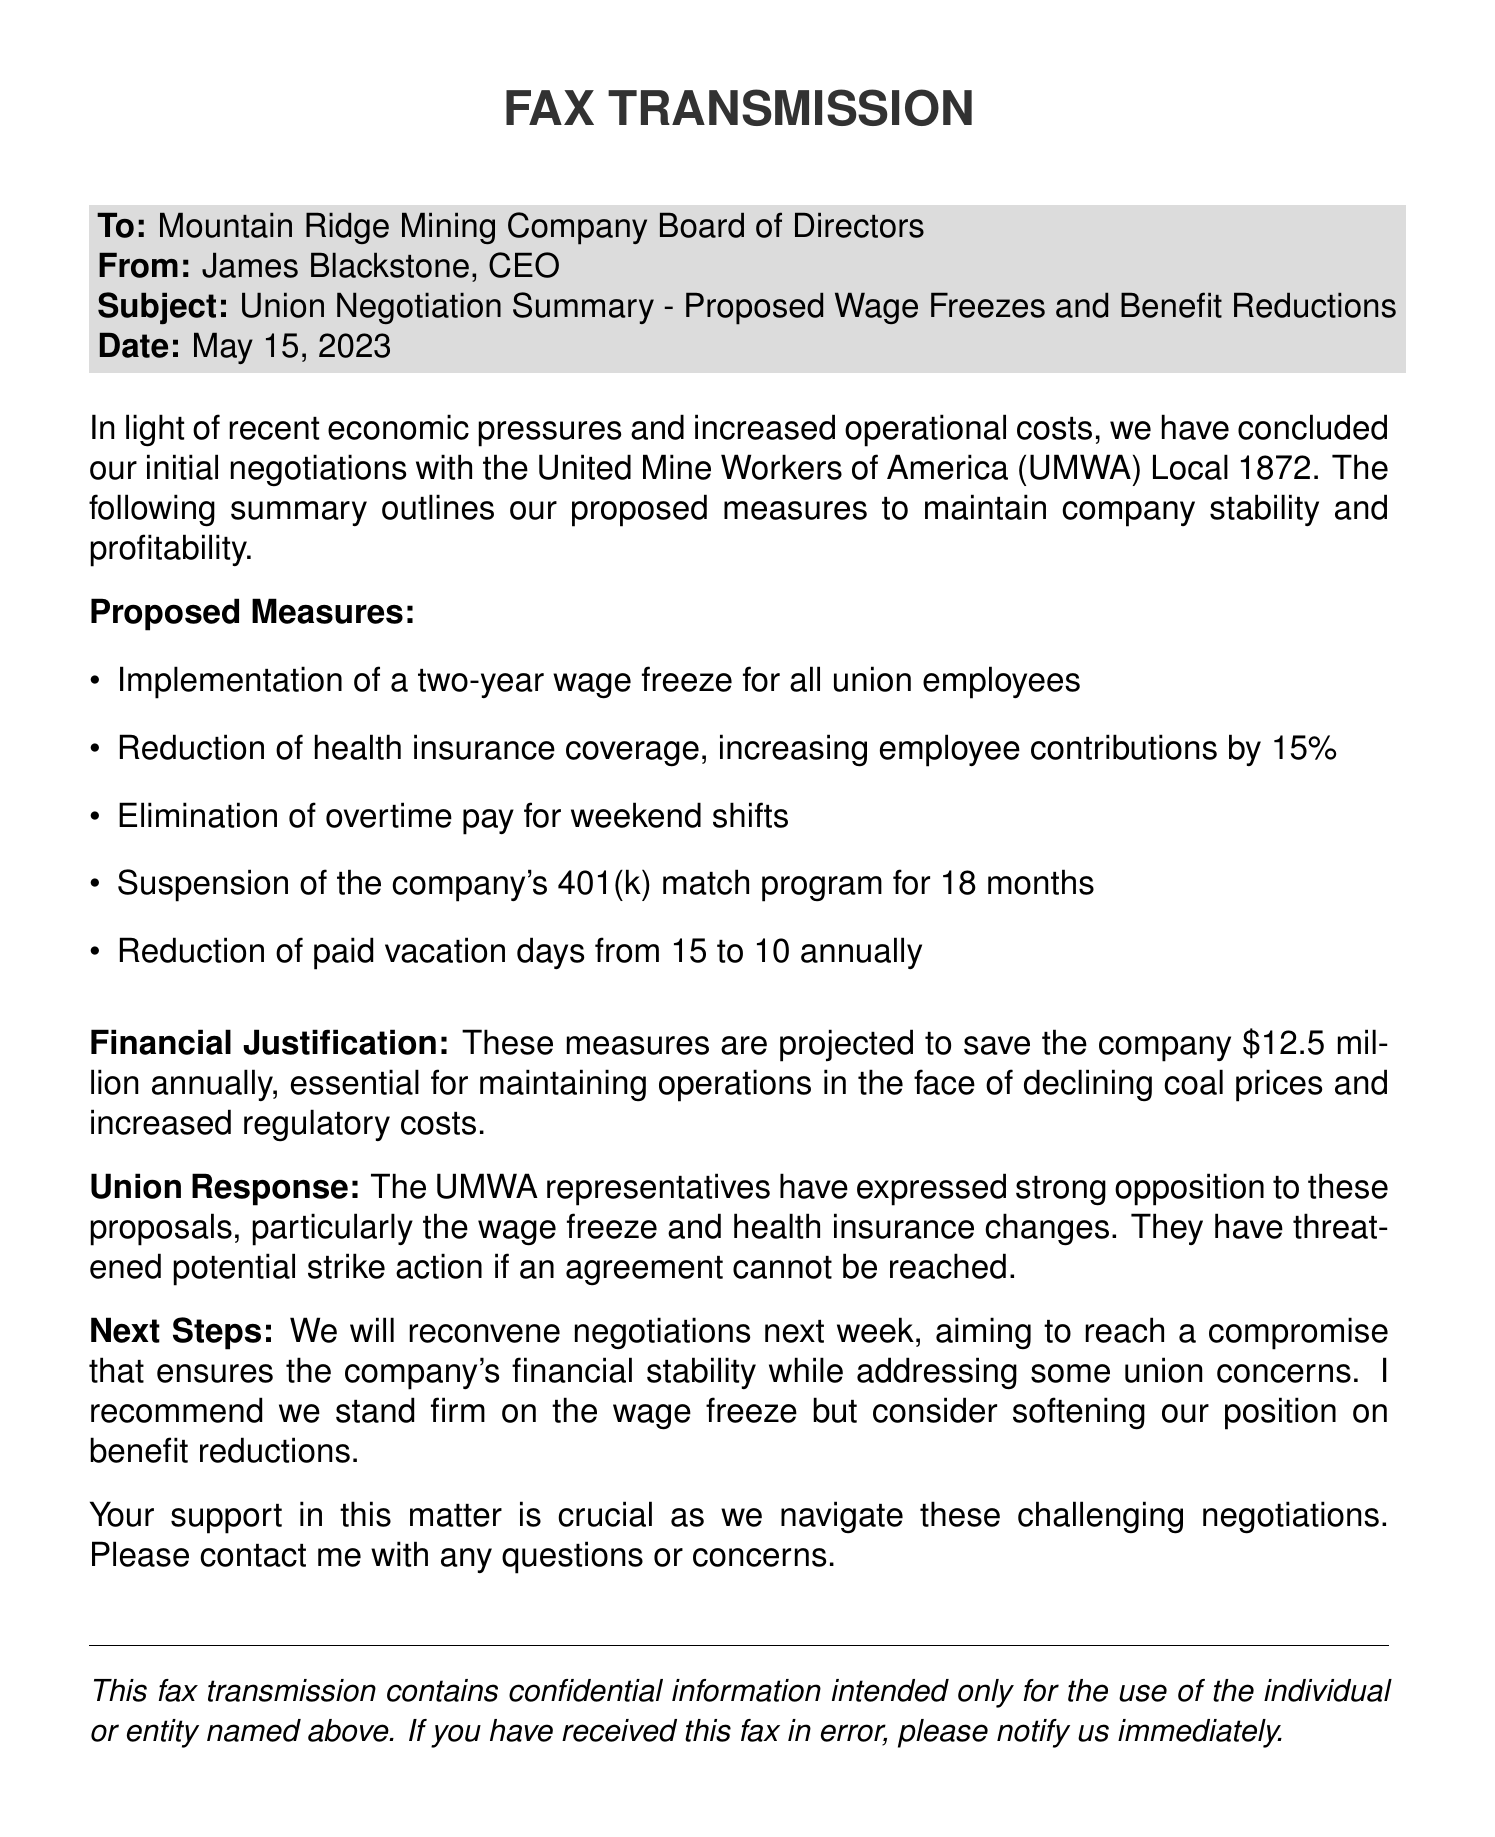what is the date of the fax? The date mentioned in the fax is provided clearly in the header section.
Answer: May 15, 2023 who sent the fax? The sender of the fax is stated at the top of the document.
Answer: James Blackstone, CEO what is the total projected savings from the proposed measures? The document specifies the total amount expected to be saved annually through the proposed measures.
Answer: $12.5 million how long will the wage freeze last? The duration of the proposed wage freeze is explicitly stated in the measures section.
Answer: two years what has the union threatened if no agreement is reached? The fax mentions the union's potential response to the negotiation outcomes.
Answer: strike action how many vacation days will be reduced? The specific change in vacation days is outlined in the proposed measures.
Answer: 5 days what percentage will employee contributions for health insurance increase? The document states the specific increase to employee contributions for health insurance.
Answer: 15% what is the next step in the negotiation process? The document outlines the next scheduled action following the current negotiation.
Answer: reconvene negotiations next week 